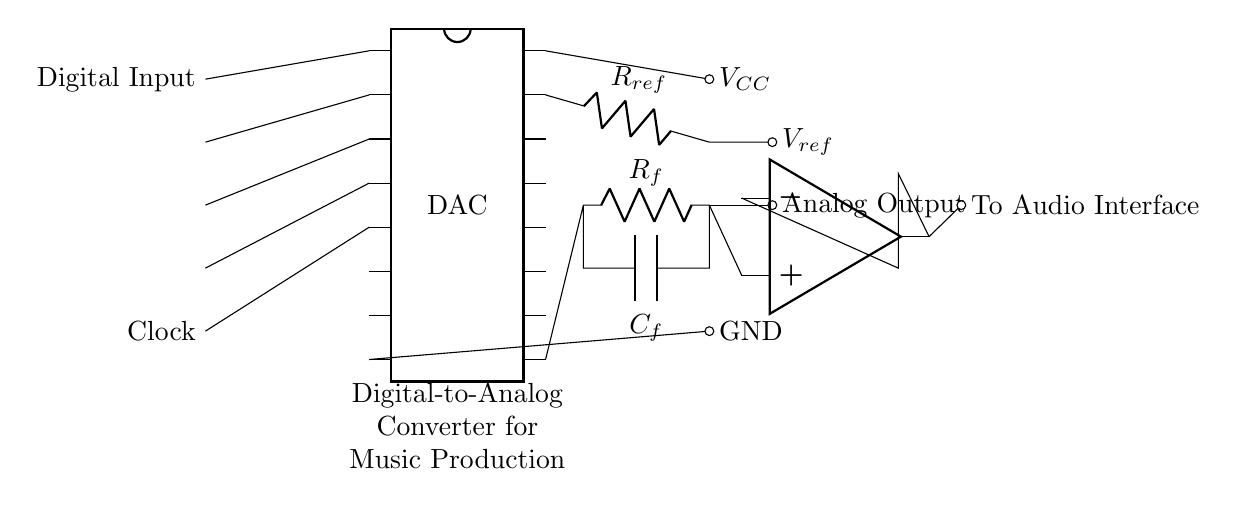What type of circuit is this? This is a digital-to-analog converter circuit, specifically designed for converting digital signals into analog outputs for music production.
Answer: Digital-to-analog converter What is the role of the reference voltage? The reference voltage, denoted as V_ref, is used as a standard for the conversion process, setting the scaling of the output relative to the digital signals.
Answer: Reference voltage How many digital input pins does the DAC have? The circuit diagram shows four digital input pins connected to the DAC, as indicated by their connections to specific pins on the component.
Answer: Four What is the purpose of the op-amp in the circuit? The operational amplifier (op-amp) amplifies the analog output signal from the DAC to ensure it is strong enough for further processing by the audio interface.
Answer: Amplification What component is connected to the output of the DAC? There is a resistor labeled R_f and a capacitor labeled C_f connected at the output, which form a part of the filtering process for the output signal.
Answer: Resistor and capacitor What are the power supply connections in this circuit? The circuit is powered by a supply voltage connected to V_CC (positive) and GND (ground), which are specific pins on the DAC indicating power input and ground connection.
Answer: V_CC and GND What does the clock input do in this circuit? The clock input provides timing signals to the DAC, ensuring that the digital signals are sampled and converted at the correct intervals for accurate output.
Answer: Timing control 